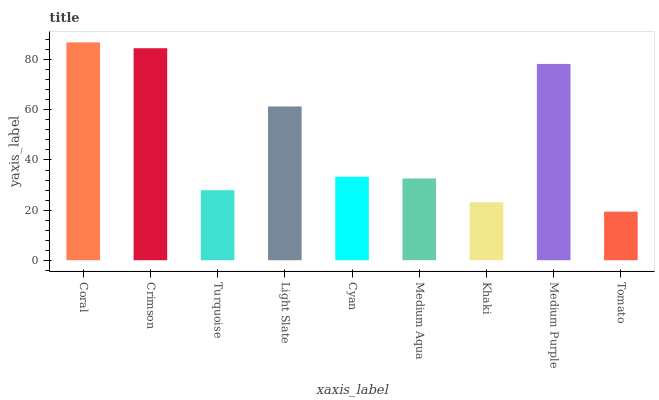Is Tomato the minimum?
Answer yes or no. Yes. Is Coral the maximum?
Answer yes or no. Yes. Is Crimson the minimum?
Answer yes or no. No. Is Crimson the maximum?
Answer yes or no. No. Is Coral greater than Crimson?
Answer yes or no. Yes. Is Crimson less than Coral?
Answer yes or no. Yes. Is Crimson greater than Coral?
Answer yes or no. No. Is Coral less than Crimson?
Answer yes or no. No. Is Cyan the high median?
Answer yes or no. Yes. Is Cyan the low median?
Answer yes or no. Yes. Is Medium Aqua the high median?
Answer yes or no. No. Is Khaki the low median?
Answer yes or no. No. 